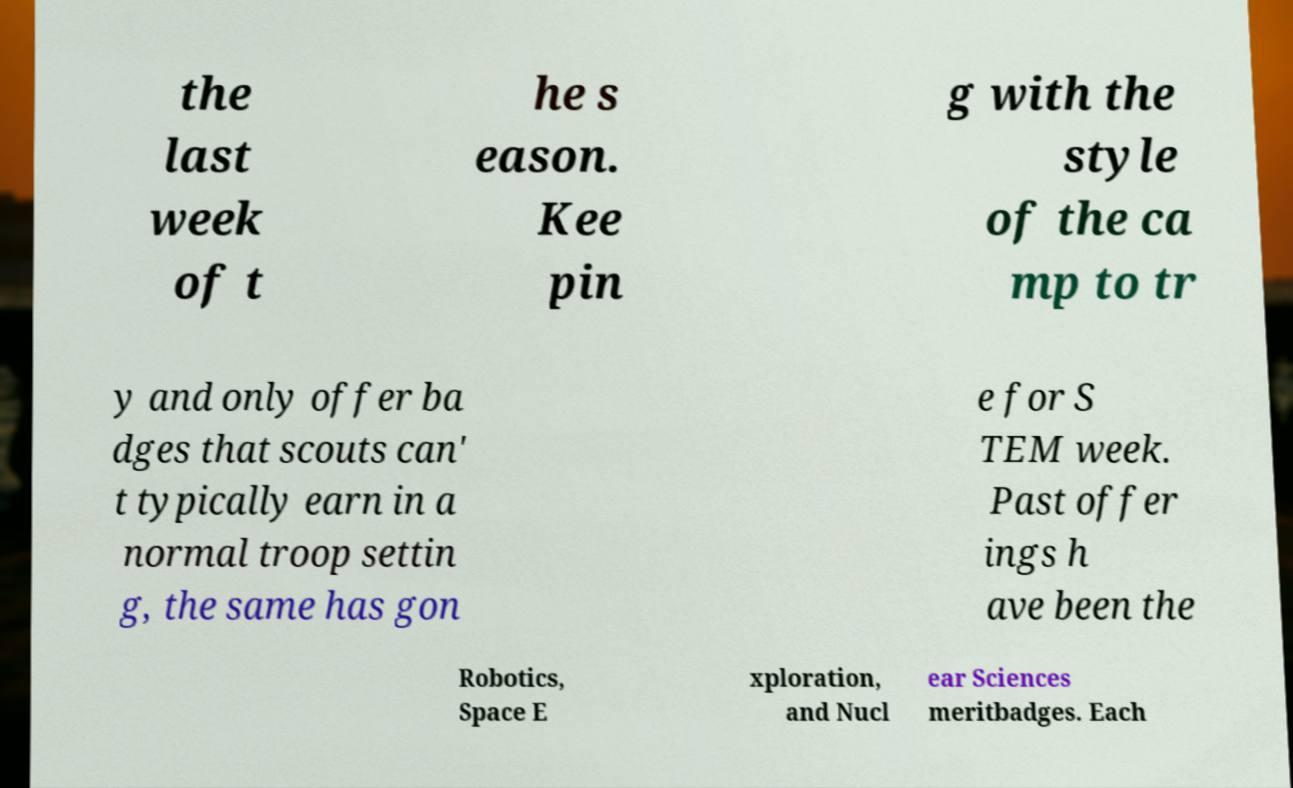Can you read and provide the text displayed in the image?This photo seems to have some interesting text. Can you extract and type it out for me? the last week of t he s eason. Kee pin g with the style of the ca mp to tr y and only offer ba dges that scouts can' t typically earn in a normal troop settin g, the same has gon e for S TEM week. Past offer ings h ave been the Robotics, Space E xploration, and Nucl ear Sciences meritbadges. Each 